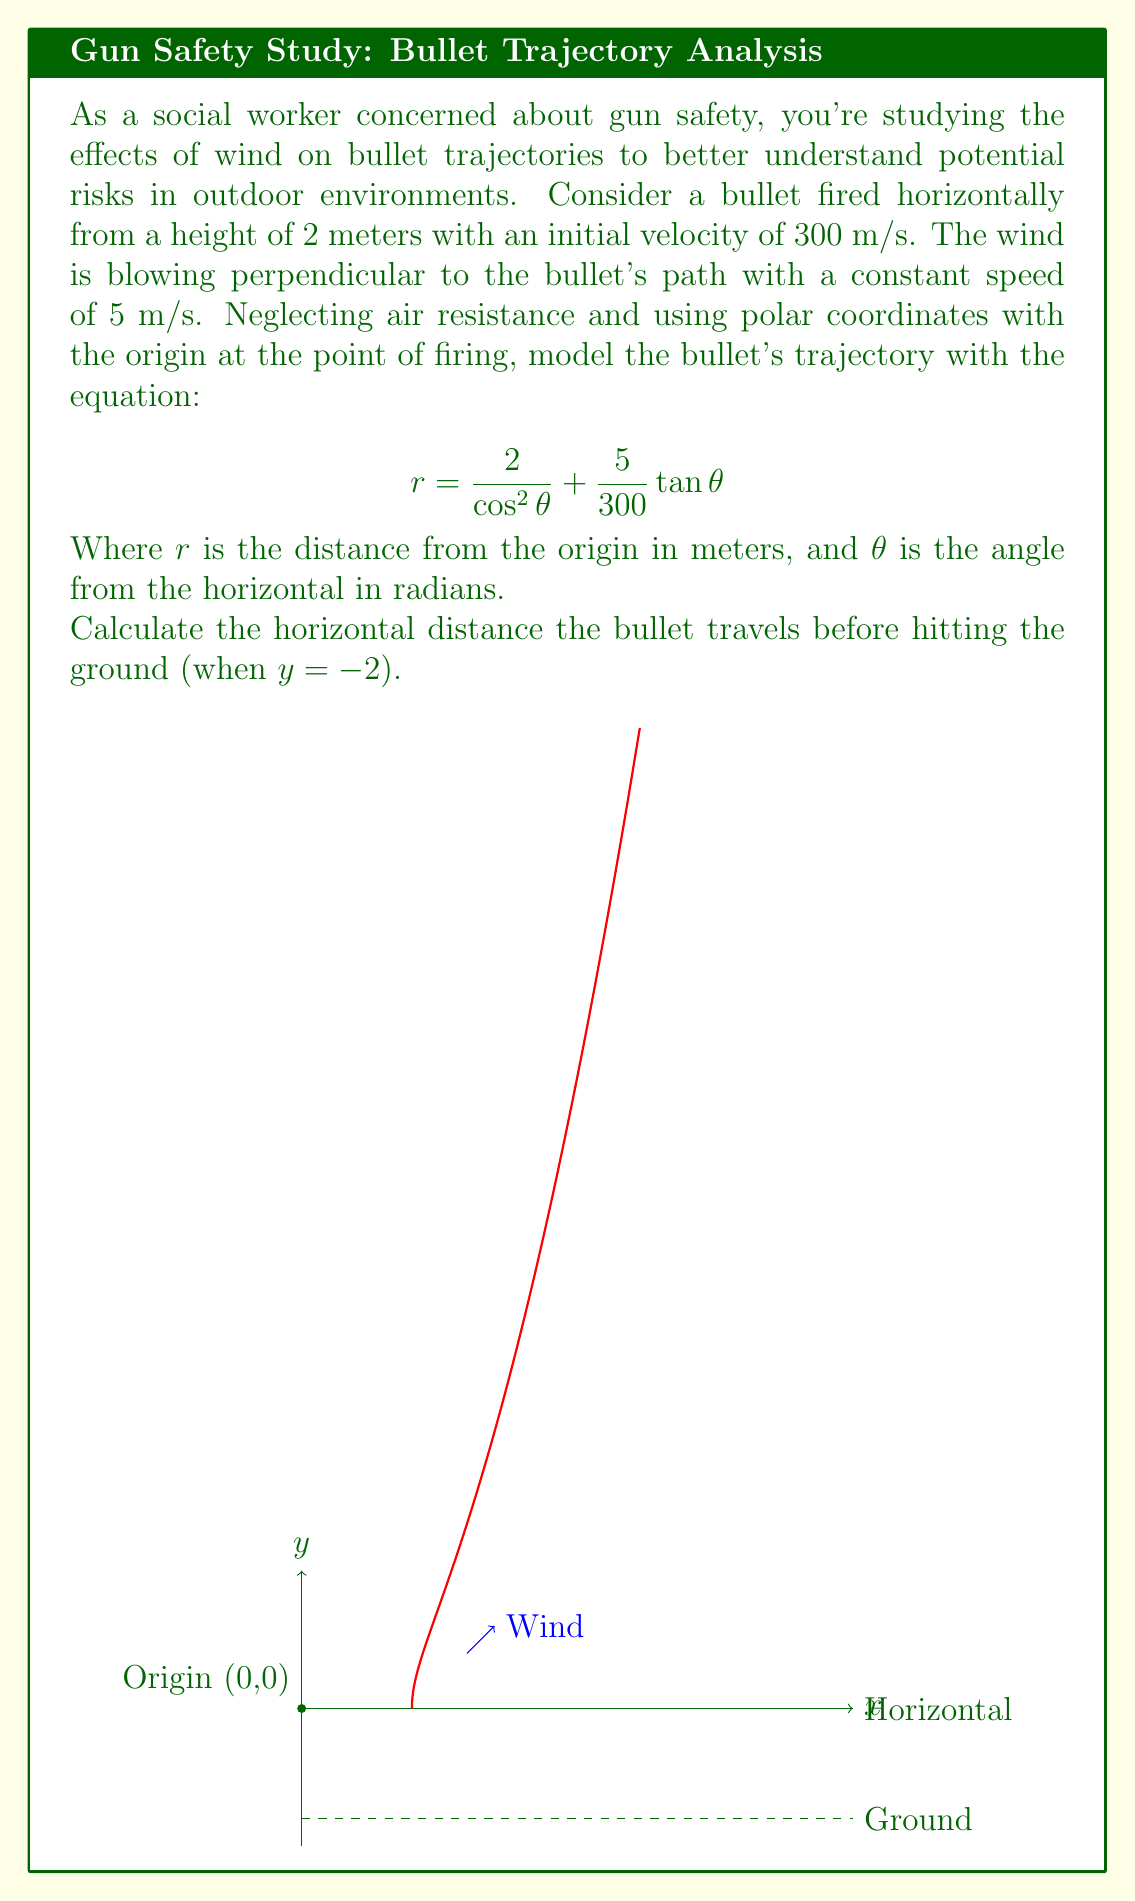Solve this math problem. Let's approach this step-by-step:

1) The bullet hits the ground when $y = -2$. In polar coordinates, this occurs when:

   $$r\sin\theta = -2$$

2) Substituting the given equation for $r$:

   $$\left(\frac{2}{\cos^2\theta} + \frac{5}{300}\tan\theta\right)\sin\theta = -2$$

3) Simplify:

   $$\frac{2\sin\theta}{\cos^2\theta} + \frac{5}{300}\sin\theta\tan\theta = -2$$

4) Use $\tan\theta = \frac{\sin\theta}{\cos\theta}$ and simplify:

   $$\frac{2\tan\theta}{\cos\theta} + \frac{5}{300}\tan^2\theta = -2$$

5) Multiply both sides by $\cos\theta$:

   $$2\tan\theta + \frac{5}{300}\tan^2\theta\cos\theta = -2\cos\theta$$

6) This equation can be solved numerically. Using a computer algebra system or numerical methods, we find:

   $$\theta \approx 1.24 \text{ radians}$$

7) The horizontal distance $x$ is given by $r\cos\theta$. Substituting our found $\theta$:

   $$x = \left(\frac{2}{\cos^2(1.24)} + \frac{5}{300}\tan(1.24)\right)\cos(1.24)$$

8) Calculating this:

   $$x \approx 9.86 \text{ meters}$$
Answer: $9.86$ meters 